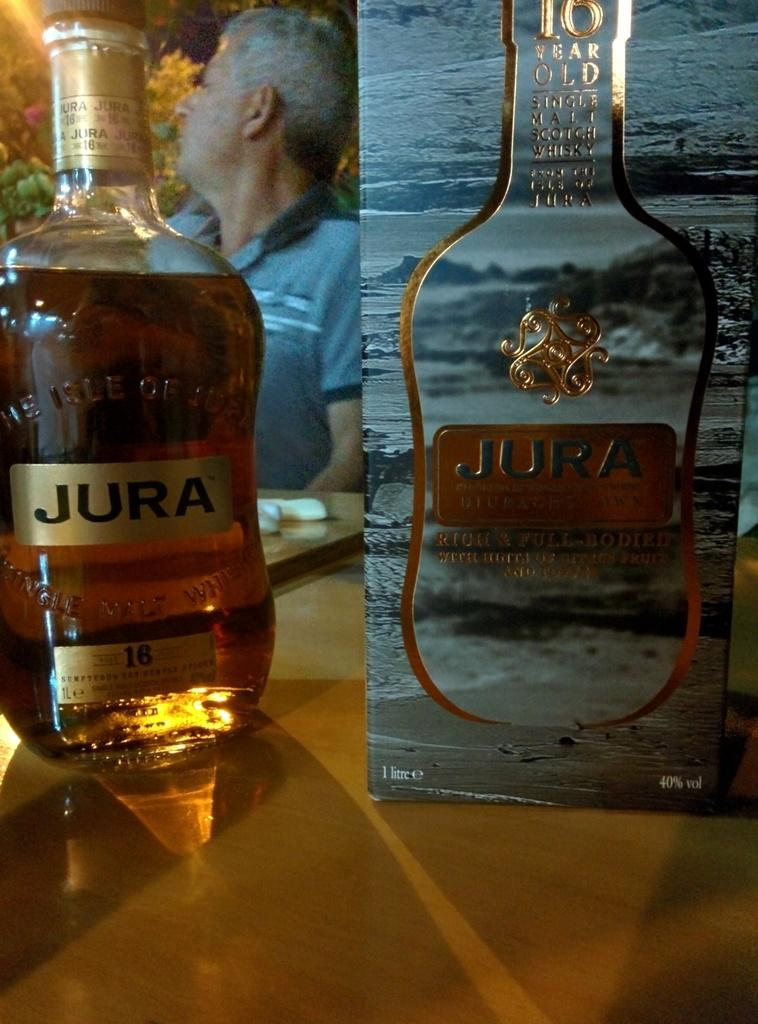<image>
Relay a brief, clear account of the picture shown. 10 Year old aged Jura Whiskey sitting in front of a man with a blue shirt. 